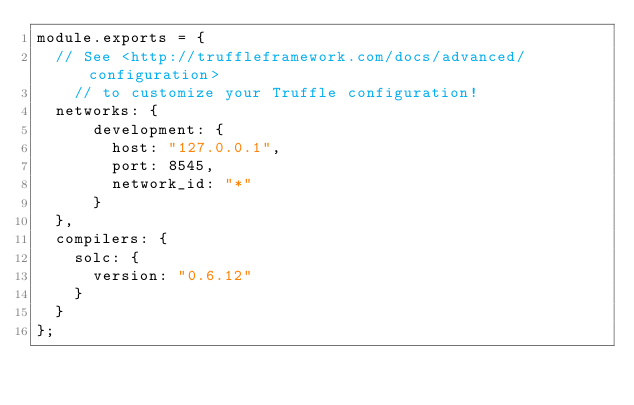<code> <loc_0><loc_0><loc_500><loc_500><_JavaScript_>module.exports = {
  // See <http://truffleframework.com/docs/advanced/configuration>
    // to customize your Truffle configuration!
  networks: {
      development: {
        host: "127.0.0.1",
        port: 8545,
        network_id: "*"
      }
  },
  compilers: {
    solc: {
      version: "0.6.12"
    }
  }
};
</code> 